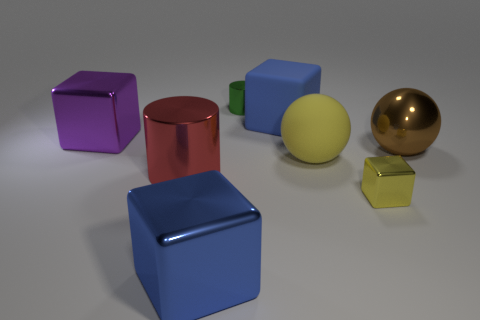Subtract all purple blocks. How many blocks are left? 3 Subtract all green cylinders. How many cylinders are left? 1 Subtract 3 cubes. How many cubes are left? 1 Add 1 small blue balls. How many objects exist? 9 Add 7 tiny things. How many tiny things are left? 9 Add 2 big red metal spheres. How many big red metal spheres exist? 2 Subtract 0 brown cubes. How many objects are left? 8 Subtract all balls. How many objects are left? 6 Subtract all cyan cubes. Subtract all purple cylinders. How many cubes are left? 4 Subtract all green balls. How many green cylinders are left? 1 